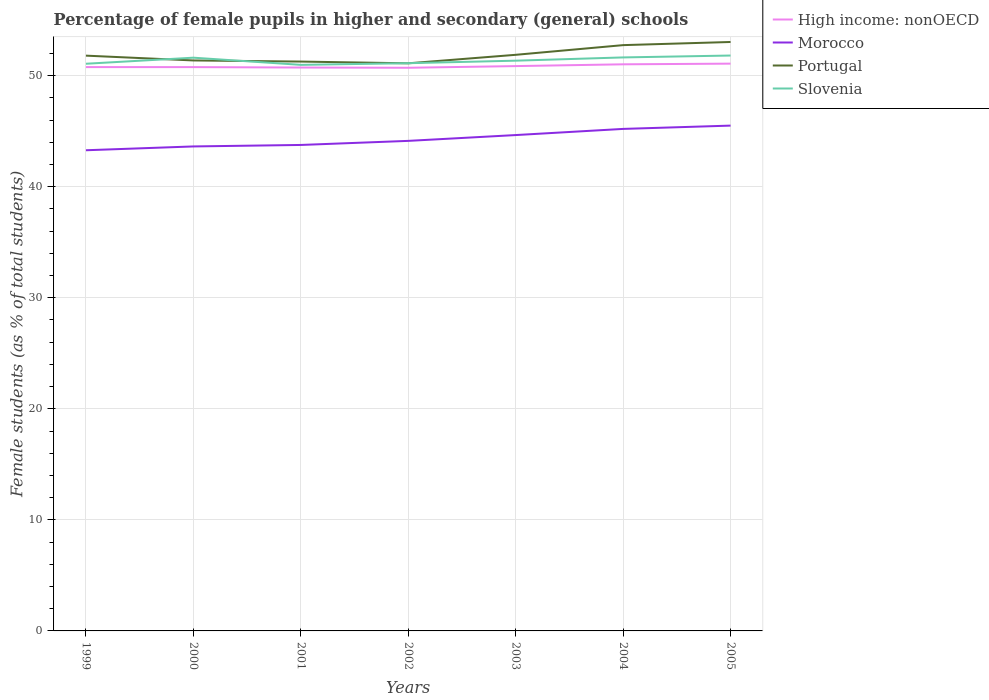Does the line corresponding to Slovenia intersect with the line corresponding to High income: nonOECD?
Offer a very short reply. No. Is the number of lines equal to the number of legend labels?
Provide a succinct answer. Yes. Across all years, what is the maximum percentage of female pupils in higher and secondary schools in High income: nonOECD?
Offer a terse response. 50.71. What is the total percentage of female pupils in higher and secondary schools in High income: nonOECD in the graph?
Give a very brief answer. -0.25. What is the difference between the highest and the second highest percentage of female pupils in higher and secondary schools in High income: nonOECD?
Offer a terse response. 0.37. What is the difference between the highest and the lowest percentage of female pupils in higher and secondary schools in High income: nonOECD?
Provide a short and direct response. 3. How many years are there in the graph?
Your response must be concise. 7. What is the difference between two consecutive major ticks on the Y-axis?
Provide a succinct answer. 10. Are the values on the major ticks of Y-axis written in scientific E-notation?
Keep it short and to the point. No. How many legend labels are there?
Offer a terse response. 4. How are the legend labels stacked?
Ensure brevity in your answer.  Vertical. What is the title of the graph?
Your answer should be compact. Percentage of female pupils in higher and secondary (general) schools. Does "Chile" appear as one of the legend labels in the graph?
Give a very brief answer. No. What is the label or title of the Y-axis?
Offer a very short reply. Female students (as % of total students). What is the Female students (as % of total students) of High income: nonOECD in 1999?
Ensure brevity in your answer.  50.77. What is the Female students (as % of total students) in Morocco in 1999?
Make the answer very short. 43.28. What is the Female students (as % of total students) of Portugal in 1999?
Make the answer very short. 51.8. What is the Female students (as % of total students) in Slovenia in 1999?
Keep it short and to the point. 51.07. What is the Female students (as % of total students) in High income: nonOECD in 2000?
Ensure brevity in your answer.  50.77. What is the Female students (as % of total students) in Morocco in 2000?
Your response must be concise. 43.62. What is the Female students (as % of total students) in Portugal in 2000?
Ensure brevity in your answer.  51.37. What is the Female students (as % of total students) of Slovenia in 2000?
Your answer should be compact. 51.61. What is the Female students (as % of total students) in High income: nonOECD in 2001?
Give a very brief answer. 50.73. What is the Female students (as % of total students) in Morocco in 2001?
Your answer should be very brief. 43.76. What is the Female students (as % of total students) of Portugal in 2001?
Offer a terse response. 51.26. What is the Female students (as % of total students) of Slovenia in 2001?
Provide a succinct answer. 50.97. What is the Female students (as % of total students) in High income: nonOECD in 2002?
Ensure brevity in your answer.  50.71. What is the Female students (as % of total students) of Morocco in 2002?
Make the answer very short. 44.12. What is the Female students (as % of total students) in Portugal in 2002?
Give a very brief answer. 51.11. What is the Female students (as % of total students) in Slovenia in 2002?
Offer a very short reply. 51.12. What is the Female students (as % of total students) of High income: nonOECD in 2003?
Ensure brevity in your answer.  50.86. What is the Female students (as % of total students) of Morocco in 2003?
Offer a terse response. 44.65. What is the Female students (as % of total students) of Portugal in 2003?
Give a very brief answer. 51.87. What is the Female students (as % of total students) of Slovenia in 2003?
Provide a short and direct response. 51.35. What is the Female students (as % of total students) in High income: nonOECD in 2004?
Ensure brevity in your answer.  51.02. What is the Female students (as % of total students) of Morocco in 2004?
Offer a very short reply. 45.2. What is the Female students (as % of total students) of Portugal in 2004?
Offer a terse response. 52.74. What is the Female students (as % of total students) of Slovenia in 2004?
Make the answer very short. 51.64. What is the Female students (as % of total students) of High income: nonOECD in 2005?
Your answer should be compact. 51.08. What is the Female students (as % of total students) of Morocco in 2005?
Your answer should be very brief. 45.5. What is the Female students (as % of total students) in Portugal in 2005?
Provide a succinct answer. 53.03. What is the Female students (as % of total students) of Slovenia in 2005?
Offer a terse response. 51.81. Across all years, what is the maximum Female students (as % of total students) in High income: nonOECD?
Your answer should be compact. 51.08. Across all years, what is the maximum Female students (as % of total students) in Morocco?
Your response must be concise. 45.5. Across all years, what is the maximum Female students (as % of total students) in Portugal?
Offer a very short reply. 53.03. Across all years, what is the maximum Female students (as % of total students) in Slovenia?
Make the answer very short. 51.81. Across all years, what is the minimum Female students (as % of total students) of High income: nonOECD?
Your response must be concise. 50.71. Across all years, what is the minimum Female students (as % of total students) of Morocco?
Ensure brevity in your answer.  43.28. Across all years, what is the minimum Female students (as % of total students) in Portugal?
Offer a terse response. 51.11. Across all years, what is the minimum Female students (as % of total students) of Slovenia?
Your answer should be very brief. 50.97. What is the total Female students (as % of total students) of High income: nonOECD in the graph?
Your answer should be very brief. 355.92. What is the total Female students (as % of total students) in Morocco in the graph?
Keep it short and to the point. 310.13. What is the total Female students (as % of total students) in Portugal in the graph?
Offer a very short reply. 363.18. What is the total Female students (as % of total students) in Slovenia in the graph?
Give a very brief answer. 359.56. What is the difference between the Female students (as % of total students) in High income: nonOECD in 1999 and that in 2000?
Offer a very short reply. 0. What is the difference between the Female students (as % of total students) in Morocco in 1999 and that in 2000?
Ensure brevity in your answer.  -0.34. What is the difference between the Female students (as % of total students) in Portugal in 1999 and that in 2000?
Offer a very short reply. 0.43. What is the difference between the Female students (as % of total students) in Slovenia in 1999 and that in 2000?
Offer a very short reply. -0.55. What is the difference between the Female students (as % of total students) of High income: nonOECD in 1999 and that in 2001?
Keep it short and to the point. 0.04. What is the difference between the Female students (as % of total students) in Morocco in 1999 and that in 2001?
Ensure brevity in your answer.  -0.48. What is the difference between the Female students (as % of total students) of Portugal in 1999 and that in 2001?
Your answer should be compact. 0.53. What is the difference between the Female students (as % of total students) of Slovenia in 1999 and that in 2001?
Offer a terse response. 0.1. What is the difference between the Female students (as % of total students) in High income: nonOECD in 1999 and that in 2002?
Your answer should be very brief. 0.06. What is the difference between the Female students (as % of total students) in Morocco in 1999 and that in 2002?
Your response must be concise. -0.85. What is the difference between the Female students (as % of total students) in Portugal in 1999 and that in 2002?
Provide a succinct answer. 0.69. What is the difference between the Female students (as % of total students) of Slovenia in 1999 and that in 2002?
Offer a terse response. -0.05. What is the difference between the Female students (as % of total students) in High income: nonOECD in 1999 and that in 2003?
Offer a very short reply. -0.09. What is the difference between the Female students (as % of total students) of Morocco in 1999 and that in 2003?
Make the answer very short. -1.37. What is the difference between the Female students (as % of total students) in Portugal in 1999 and that in 2003?
Your answer should be very brief. -0.07. What is the difference between the Female students (as % of total students) in Slovenia in 1999 and that in 2003?
Ensure brevity in your answer.  -0.28. What is the difference between the Female students (as % of total students) of Morocco in 1999 and that in 2004?
Ensure brevity in your answer.  -1.92. What is the difference between the Female students (as % of total students) of Portugal in 1999 and that in 2004?
Provide a short and direct response. -0.95. What is the difference between the Female students (as % of total students) in Slovenia in 1999 and that in 2004?
Offer a terse response. -0.57. What is the difference between the Female students (as % of total students) of High income: nonOECD in 1999 and that in 2005?
Provide a short and direct response. -0.31. What is the difference between the Female students (as % of total students) in Morocco in 1999 and that in 2005?
Provide a short and direct response. -2.22. What is the difference between the Female students (as % of total students) of Portugal in 1999 and that in 2005?
Your response must be concise. -1.23. What is the difference between the Female students (as % of total students) of Slovenia in 1999 and that in 2005?
Offer a very short reply. -0.74. What is the difference between the Female students (as % of total students) in High income: nonOECD in 2000 and that in 2001?
Your response must be concise. 0.04. What is the difference between the Female students (as % of total students) of Morocco in 2000 and that in 2001?
Offer a very short reply. -0.13. What is the difference between the Female students (as % of total students) of Portugal in 2000 and that in 2001?
Give a very brief answer. 0.1. What is the difference between the Female students (as % of total students) in Slovenia in 2000 and that in 2001?
Keep it short and to the point. 0.65. What is the difference between the Female students (as % of total students) of High income: nonOECD in 2000 and that in 2002?
Your answer should be very brief. 0.06. What is the difference between the Female students (as % of total students) of Morocco in 2000 and that in 2002?
Provide a short and direct response. -0.5. What is the difference between the Female students (as % of total students) of Portugal in 2000 and that in 2002?
Provide a short and direct response. 0.26. What is the difference between the Female students (as % of total students) in Slovenia in 2000 and that in 2002?
Provide a short and direct response. 0.5. What is the difference between the Female students (as % of total students) of High income: nonOECD in 2000 and that in 2003?
Give a very brief answer. -0.09. What is the difference between the Female students (as % of total students) of Morocco in 2000 and that in 2003?
Offer a terse response. -1.02. What is the difference between the Female students (as % of total students) in Portugal in 2000 and that in 2003?
Give a very brief answer. -0.51. What is the difference between the Female students (as % of total students) of Slovenia in 2000 and that in 2003?
Make the answer very short. 0.27. What is the difference between the Female students (as % of total students) in High income: nonOECD in 2000 and that in 2004?
Your answer should be very brief. -0.25. What is the difference between the Female students (as % of total students) of Morocco in 2000 and that in 2004?
Your response must be concise. -1.58. What is the difference between the Female students (as % of total students) in Portugal in 2000 and that in 2004?
Your answer should be very brief. -1.38. What is the difference between the Female students (as % of total students) in Slovenia in 2000 and that in 2004?
Your answer should be compact. -0.02. What is the difference between the Female students (as % of total students) of High income: nonOECD in 2000 and that in 2005?
Offer a terse response. -0.31. What is the difference between the Female students (as % of total students) in Morocco in 2000 and that in 2005?
Provide a succinct answer. -1.87. What is the difference between the Female students (as % of total students) in Portugal in 2000 and that in 2005?
Provide a succinct answer. -1.66. What is the difference between the Female students (as % of total students) in Slovenia in 2000 and that in 2005?
Provide a succinct answer. -0.19. What is the difference between the Female students (as % of total students) of High income: nonOECD in 2001 and that in 2002?
Offer a very short reply. 0.02. What is the difference between the Female students (as % of total students) in Morocco in 2001 and that in 2002?
Your response must be concise. -0.37. What is the difference between the Female students (as % of total students) in Portugal in 2001 and that in 2002?
Keep it short and to the point. 0.16. What is the difference between the Female students (as % of total students) of Slovenia in 2001 and that in 2002?
Keep it short and to the point. -0.15. What is the difference between the Female students (as % of total students) of High income: nonOECD in 2001 and that in 2003?
Provide a succinct answer. -0.13. What is the difference between the Female students (as % of total students) in Morocco in 2001 and that in 2003?
Ensure brevity in your answer.  -0.89. What is the difference between the Female students (as % of total students) in Portugal in 2001 and that in 2003?
Keep it short and to the point. -0.61. What is the difference between the Female students (as % of total students) in Slovenia in 2001 and that in 2003?
Offer a very short reply. -0.38. What is the difference between the Female students (as % of total students) in High income: nonOECD in 2001 and that in 2004?
Your answer should be compact. -0.29. What is the difference between the Female students (as % of total students) in Morocco in 2001 and that in 2004?
Your response must be concise. -1.44. What is the difference between the Female students (as % of total students) of Portugal in 2001 and that in 2004?
Offer a very short reply. -1.48. What is the difference between the Female students (as % of total students) in Slovenia in 2001 and that in 2004?
Make the answer very short. -0.67. What is the difference between the Female students (as % of total students) of High income: nonOECD in 2001 and that in 2005?
Your answer should be compact. -0.35. What is the difference between the Female students (as % of total students) in Morocco in 2001 and that in 2005?
Keep it short and to the point. -1.74. What is the difference between the Female students (as % of total students) in Portugal in 2001 and that in 2005?
Provide a short and direct response. -1.76. What is the difference between the Female students (as % of total students) of Slovenia in 2001 and that in 2005?
Offer a terse response. -0.84. What is the difference between the Female students (as % of total students) in High income: nonOECD in 2002 and that in 2003?
Ensure brevity in your answer.  -0.15. What is the difference between the Female students (as % of total students) of Morocco in 2002 and that in 2003?
Offer a very short reply. -0.52. What is the difference between the Female students (as % of total students) in Portugal in 2002 and that in 2003?
Your answer should be very brief. -0.76. What is the difference between the Female students (as % of total students) of Slovenia in 2002 and that in 2003?
Give a very brief answer. -0.23. What is the difference between the Female students (as % of total students) of High income: nonOECD in 2002 and that in 2004?
Give a very brief answer. -0.31. What is the difference between the Female students (as % of total students) of Morocco in 2002 and that in 2004?
Keep it short and to the point. -1.08. What is the difference between the Female students (as % of total students) of Portugal in 2002 and that in 2004?
Ensure brevity in your answer.  -1.64. What is the difference between the Female students (as % of total students) of Slovenia in 2002 and that in 2004?
Offer a very short reply. -0.52. What is the difference between the Female students (as % of total students) in High income: nonOECD in 2002 and that in 2005?
Give a very brief answer. -0.37. What is the difference between the Female students (as % of total students) of Morocco in 2002 and that in 2005?
Your response must be concise. -1.37. What is the difference between the Female students (as % of total students) in Portugal in 2002 and that in 2005?
Provide a succinct answer. -1.92. What is the difference between the Female students (as % of total students) in Slovenia in 2002 and that in 2005?
Your answer should be very brief. -0.69. What is the difference between the Female students (as % of total students) of High income: nonOECD in 2003 and that in 2004?
Keep it short and to the point. -0.16. What is the difference between the Female students (as % of total students) of Morocco in 2003 and that in 2004?
Ensure brevity in your answer.  -0.55. What is the difference between the Female students (as % of total students) of Portugal in 2003 and that in 2004?
Keep it short and to the point. -0.87. What is the difference between the Female students (as % of total students) of Slovenia in 2003 and that in 2004?
Your answer should be compact. -0.29. What is the difference between the Female students (as % of total students) in High income: nonOECD in 2003 and that in 2005?
Your answer should be very brief. -0.22. What is the difference between the Female students (as % of total students) in Morocco in 2003 and that in 2005?
Offer a terse response. -0.85. What is the difference between the Female students (as % of total students) of Portugal in 2003 and that in 2005?
Your answer should be compact. -1.15. What is the difference between the Female students (as % of total students) in Slovenia in 2003 and that in 2005?
Your answer should be compact. -0.46. What is the difference between the Female students (as % of total students) of High income: nonOECD in 2004 and that in 2005?
Keep it short and to the point. -0.06. What is the difference between the Female students (as % of total students) in Morocco in 2004 and that in 2005?
Offer a very short reply. -0.3. What is the difference between the Female students (as % of total students) of Portugal in 2004 and that in 2005?
Provide a succinct answer. -0.28. What is the difference between the Female students (as % of total students) of Slovenia in 2004 and that in 2005?
Ensure brevity in your answer.  -0.17. What is the difference between the Female students (as % of total students) in High income: nonOECD in 1999 and the Female students (as % of total students) in Morocco in 2000?
Offer a terse response. 7.14. What is the difference between the Female students (as % of total students) of High income: nonOECD in 1999 and the Female students (as % of total students) of Portugal in 2000?
Offer a terse response. -0.6. What is the difference between the Female students (as % of total students) of High income: nonOECD in 1999 and the Female students (as % of total students) of Slovenia in 2000?
Ensure brevity in your answer.  -0.85. What is the difference between the Female students (as % of total students) of Morocco in 1999 and the Female students (as % of total students) of Portugal in 2000?
Your response must be concise. -8.09. What is the difference between the Female students (as % of total students) in Morocco in 1999 and the Female students (as % of total students) in Slovenia in 2000?
Make the answer very short. -8.34. What is the difference between the Female students (as % of total students) of Portugal in 1999 and the Female students (as % of total students) of Slovenia in 2000?
Offer a terse response. 0.18. What is the difference between the Female students (as % of total students) of High income: nonOECD in 1999 and the Female students (as % of total students) of Morocco in 2001?
Give a very brief answer. 7.01. What is the difference between the Female students (as % of total students) in High income: nonOECD in 1999 and the Female students (as % of total students) in Portugal in 2001?
Your response must be concise. -0.5. What is the difference between the Female students (as % of total students) of High income: nonOECD in 1999 and the Female students (as % of total students) of Slovenia in 2001?
Make the answer very short. -0.2. What is the difference between the Female students (as % of total students) in Morocco in 1999 and the Female students (as % of total students) in Portugal in 2001?
Your answer should be compact. -7.99. What is the difference between the Female students (as % of total students) of Morocco in 1999 and the Female students (as % of total students) of Slovenia in 2001?
Make the answer very short. -7.69. What is the difference between the Female students (as % of total students) in Portugal in 1999 and the Female students (as % of total students) in Slovenia in 2001?
Your answer should be very brief. 0.83. What is the difference between the Female students (as % of total students) in High income: nonOECD in 1999 and the Female students (as % of total students) in Morocco in 2002?
Your response must be concise. 6.64. What is the difference between the Female students (as % of total students) of High income: nonOECD in 1999 and the Female students (as % of total students) of Portugal in 2002?
Your answer should be very brief. -0.34. What is the difference between the Female students (as % of total students) in High income: nonOECD in 1999 and the Female students (as % of total students) in Slovenia in 2002?
Give a very brief answer. -0.35. What is the difference between the Female students (as % of total students) of Morocco in 1999 and the Female students (as % of total students) of Portugal in 2002?
Make the answer very short. -7.83. What is the difference between the Female students (as % of total students) of Morocco in 1999 and the Female students (as % of total students) of Slovenia in 2002?
Provide a short and direct response. -7.84. What is the difference between the Female students (as % of total students) in Portugal in 1999 and the Female students (as % of total students) in Slovenia in 2002?
Ensure brevity in your answer.  0.68. What is the difference between the Female students (as % of total students) of High income: nonOECD in 1999 and the Female students (as % of total students) of Morocco in 2003?
Offer a terse response. 6.12. What is the difference between the Female students (as % of total students) in High income: nonOECD in 1999 and the Female students (as % of total students) in Portugal in 2003?
Provide a short and direct response. -1.11. What is the difference between the Female students (as % of total students) of High income: nonOECD in 1999 and the Female students (as % of total students) of Slovenia in 2003?
Offer a terse response. -0.58. What is the difference between the Female students (as % of total students) of Morocco in 1999 and the Female students (as % of total students) of Portugal in 2003?
Offer a terse response. -8.59. What is the difference between the Female students (as % of total students) of Morocco in 1999 and the Female students (as % of total students) of Slovenia in 2003?
Provide a short and direct response. -8.07. What is the difference between the Female students (as % of total students) in Portugal in 1999 and the Female students (as % of total students) in Slovenia in 2003?
Your answer should be very brief. 0.45. What is the difference between the Female students (as % of total students) in High income: nonOECD in 1999 and the Female students (as % of total students) in Morocco in 2004?
Your response must be concise. 5.57. What is the difference between the Female students (as % of total students) in High income: nonOECD in 1999 and the Female students (as % of total students) in Portugal in 2004?
Your response must be concise. -1.98. What is the difference between the Female students (as % of total students) in High income: nonOECD in 1999 and the Female students (as % of total students) in Slovenia in 2004?
Provide a short and direct response. -0.87. What is the difference between the Female students (as % of total students) in Morocco in 1999 and the Female students (as % of total students) in Portugal in 2004?
Provide a short and direct response. -9.47. What is the difference between the Female students (as % of total students) of Morocco in 1999 and the Female students (as % of total students) of Slovenia in 2004?
Make the answer very short. -8.36. What is the difference between the Female students (as % of total students) in Portugal in 1999 and the Female students (as % of total students) in Slovenia in 2004?
Your answer should be compact. 0.16. What is the difference between the Female students (as % of total students) of High income: nonOECD in 1999 and the Female students (as % of total students) of Morocco in 2005?
Offer a very short reply. 5.27. What is the difference between the Female students (as % of total students) of High income: nonOECD in 1999 and the Female students (as % of total students) of Portugal in 2005?
Provide a succinct answer. -2.26. What is the difference between the Female students (as % of total students) in High income: nonOECD in 1999 and the Female students (as % of total students) in Slovenia in 2005?
Provide a succinct answer. -1.04. What is the difference between the Female students (as % of total students) of Morocco in 1999 and the Female students (as % of total students) of Portugal in 2005?
Keep it short and to the point. -9.75. What is the difference between the Female students (as % of total students) in Morocco in 1999 and the Female students (as % of total students) in Slovenia in 2005?
Your answer should be very brief. -8.53. What is the difference between the Female students (as % of total students) in Portugal in 1999 and the Female students (as % of total students) in Slovenia in 2005?
Your answer should be compact. -0.01. What is the difference between the Female students (as % of total students) of High income: nonOECD in 2000 and the Female students (as % of total students) of Morocco in 2001?
Your answer should be compact. 7.01. What is the difference between the Female students (as % of total students) of High income: nonOECD in 2000 and the Female students (as % of total students) of Portugal in 2001?
Your answer should be compact. -0.5. What is the difference between the Female students (as % of total students) of High income: nonOECD in 2000 and the Female students (as % of total students) of Slovenia in 2001?
Your answer should be compact. -0.2. What is the difference between the Female students (as % of total students) in Morocco in 2000 and the Female students (as % of total students) in Portugal in 2001?
Offer a very short reply. -7.64. What is the difference between the Female students (as % of total students) of Morocco in 2000 and the Female students (as % of total students) of Slovenia in 2001?
Offer a terse response. -7.35. What is the difference between the Female students (as % of total students) in Portugal in 2000 and the Female students (as % of total students) in Slovenia in 2001?
Your answer should be very brief. 0.4. What is the difference between the Female students (as % of total students) in High income: nonOECD in 2000 and the Female students (as % of total students) in Morocco in 2002?
Your response must be concise. 6.64. What is the difference between the Female students (as % of total students) of High income: nonOECD in 2000 and the Female students (as % of total students) of Portugal in 2002?
Keep it short and to the point. -0.34. What is the difference between the Female students (as % of total students) of High income: nonOECD in 2000 and the Female students (as % of total students) of Slovenia in 2002?
Provide a succinct answer. -0.35. What is the difference between the Female students (as % of total students) of Morocco in 2000 and the Female students (as % of total students) of Portugal in 2002?
Keep it short and to the point. -7.48. What is the difference between the Female students (as % of total students) of Morocco in 2000 and the Female students (as % of total students) of Slovenia in 2002?
Your response must be concise. -7.49. What is the difference between the Female students (as % of total students) in Portugal in 2000 and the Female students (as % of total students) in Slovenia in 2002?
Provide a short and direct response. 0.25. What is the difference between the Female students (as % of total students) of High income: nonOECD in 2000 and the Female students (as % of total students) of Morocco in 2003?
Provide a short and direct response. 6.12. What is the difference between the Female students (as % of total students) in High income: nonOECD in 2000 and the Female students (as % of total students) in Portugal in 2003?
Make the answer very short. -1.11. What is the difference between the Female students (as % of total students) in High income: nonOECD in 2000 and the Female students (as % of total students) in Slovenia in 2003?
Provide a short and direct response. -0.58. What is the difference between the Female students (as % of total students) of Morocco in 2000 and the Female students (as % of total students) of Portugal in 2003?
Give a very brief answer. -8.25. What is the difference between the Female students (as % of total students) of Morocco in 2000 and the Female students (as % of total students) of Slovenia in 2003?
Ensure brevity in your answer.  -7.72. What is the difference between the Female students (as % of total students) in Portugal in 2000 and the Female students (as % of total students) in Slovenia in 2003?
Keep it short and to the point. 0.02. What is the difference between the Female students (as % of total students) of High income: nonOECD in 2000 and the Female students (as % of total students) of Morocco in 2004?
Keep it short and to the point. 5.56. What is the difference between the Female students (as % of total students) of High income: nonOECD in 2000 and the Female students (as % of total students) of Portugal in 2004?
Your answer should be very brief. -1.98. What is the difference between the Female students (as % of total students) of High income: nonOECD in 2000 and the Female students (as % of total students) of Slovenia in 2004?
Give a very brief answer. -0.87. What is the difference between the Female students (as % of total students) in Morocco in 2000 and the Female students (as % of total students) in Portugal in 2004?
Give a very brief answer. -9.12. What is the difference between the Female students (as % of total students) of Morocco in 2000 and the Female students (as % of total students) of Slovenia in 2004?
Your answer should be very brief. -8.02. What is the difference between the Female students (as % of total students) of Portugal in 2000 and the Female students (as % of total students) of Slovenia in 2004?
Your answer should be very brief. -0.27. What is the difference between the Female students (as % of total students) of High income: nonOECD in 2000 and the Female students (as % of total students) of Morocco in 2005?
Offer a very short reply. 5.27. What is the difference between the Female students (as % of total students) of High income: nonOECD in 2000 and the Female students (as % of total students) of Portugal in 2005?
Ensure brevity in your answer.  -2.26. What is the difference between the Female students (as % of total students) in High income: nonOECD in 2000 and the Female students (as % of total students) in Slovenia in 2005?
Ensure brevity in your answer.  -1.04. What is the difference between the Female students (as % of total students) in Morocco in 2000 and the Female students (as % of total students) in Portugal in 2005?
Your answer should be very brief. -9.4. What is the difference between the Female students (as % of total students) in Morocco in 2000 and the Female students (as % of total students) in Slovenia in 2005?
Your answer should be compact. -8.19. What is the difference between the Female students (as % of total students) in Portugal in 2000 and the Female students (as % of total students) in Slovenia in 2005?
Give a very brief answer. -0.44. What is the difference between the Female students (as % of total students) of High income: nonOECD in 2001 and the Female students (as % of total students) of Morocco in 2002?
Provide a succinct answer. 6.6. What is the difference between the Female students (as % of total students) of High income: nonOECD in 2001 and the Female students (as % of total students) of Portugal in 2002?
Your answer should be very brief. -0.38. What is the difference between the Female students (as % of total students) of High income: nonOECD in 2001 and the Female students (as % of total students) of Slovenia in 2002?
Offer a very short reply. -0.39. What is the difference between the Female students (as % of total students) in Morocco in 2001 and the Female students (as % of total students) in Portugal in 2002?
Ensure brevity in your answer.  -7.35. What is the difference between the Female students (as % of total students) of Morocco in 2001 and the Female students (as % of total students) of Slovenia in 2002?
Make the answer very short. -7.36. What is the difference between the Female students (as % of total students) in Portugal in 2001 and the Female students (as % of total students) in Slovenia in 2002?
Make the answer very short. 0.15. What is the difference between the Female students (as % of total students) in High income: nonOECD in 2001 and the Female students (as % of total students) in Morocco in 2003?
Give a very brief answer. 6.08. What is the difference between the Female students (as % of total students) in High income: nonOECD in 2001 and the Female students (as % of total students) in Portugal in 2003?
Your answer should be very brief. -1.15. What is the difference between the Female students (as % of total students) in High income: nonOECD in 2001 and the Female students (as % of total students) in Slovenia in 2003?
Offer a very short reply. -0.62. What is the difference between the Female students (as % of total students) of Morocco in 2001 and the Female students (as % of total students) of Portugal in 2003?
Offer a very short reply. -8.12. What is the difference between the Female students (as % of total students) of Morocco in 2001 and the Female students (as % of total students) of Slovenia in 2003?
Make the answer very short. -7.59. What is the difference between the Female students (as % of total students) of Portugal in 2001 and the Female students (as % of total students) of Slovenia in 2003?
Ensure brevity in your answer.  -0.08. What is the difference between the Female students (as % of total students) in High income: nonOECD in 2001 and the Female students (as % of total students) in Morocco in 2004?
Provide a short and direct response. 5.53. What is the difference between the Female students (as % of total students) in High income: nonOECD in 2001 and the Female students (as % of total students) in Portugal in 2004?
Your answer should be compact. -2.02. What is the difference between the Female students (as % of total students) of High income: nonOECD in 2001 and the Female students (as % of total students) of Slovenia in 2004?
Your answer should be very brief. -0.91. What is the difference between the Female students (as % of total students) of Morocco in 2001 and the Female students (as % of total students) of Portugal in 2004?
Offer a terse response. -8.99. What is the difference between the Female students (as % of total students) of Morocco in 2001 and the Female students (as % of total students) of Slovenia in 2004?
Your answer should be very brief. -7.88. What is the difference between the Female students (as % of total students) of Portugal in 2001 and the Female students (as % of total students) of Slovenia in 2004?
Offer a terse response. -0.37. What is the difference between the Female students (as % of total students) in High income: nonOECD in 2001 and the Female students (as % of total students) in Morocco in 2005?
Your answer should be compact. 5.23. What is the difference between the Female students (as % of total students) in High income: nonOECD in 2001 and the Female students (as % of total students) in Portugal in 2005?
Provide a succinct answer. -2.3. What is the difference between the Female students (as % of total students) in High income: nonOECD in 2001 and the Female students (as % of total students) in Slovenia in 2005?
Give a very brief answer. -1.08. What is the difference between the Female students (as % of total students) in Morocco in 2001 and the Female students (as % of total students) in Portugal in 2005?
Make the answer very short. -9.27. What is the difference between the Female students (as % of total students) in Morocco in 2001 and the Female students (as % of total students) in Slovenia in 2005?
Keep it short and to the point. -8.05. What is the difference between the Female students (as % of total students) of Portugal in 2001 and the Female students (as % of total students) of Slovenia in 2005?
Your answer should be compact. -0.54. What is the difference between the Female students (as % of total students) in High income: nonOECD in 2002 and the Female students (as % of total students) in Morocco in 2003?
Ensure brevity in your answer.  6.06. What is the difference between the Female students (as % of total students) of High income: nonOECD in 2002 and the Female students (as % of total students) of Portugal in 2003?
Your answer should be very brief. -1.17. What is the difference between the Female students (as % of total students) in High income: nonOECD in 2002 and the Female students (as % of total students) in Slovenia in 2003?
Make the answer very short. -0.64. What is the difference between the Female students (as % of total students) in Morocco in 2002 and the Female students (as % of total students) in Portugal in 2003?
Your answer should be compact. -7.75. What is the difference between the Female students (as % of total students) in Morocco in 2002 and the Female students (as % of total students) in Slovenia in 2003?
Keep it short and to the point. -7.22. What is the difference between the Female students (as % of total students) of Portugal in 2002 and the Female students (as % of total students) of Slovenia in 2003?
Offer a very short reply. -0.24. What is the difference between the Female students (as % of total students) of High income: nonOECD in 2002 and the Female students (as % of total students) of Morocco in 2004?
Provide a succinct answer. 5.5. What is the difference between the Female students (as % of total students) in High income: nonOECD in 2002 and the Female students (as % of total students) in Portugal in 2004?
Offer a terse response. -2.04. What is the difference between the Female students (as % of total students) of High income: nonOECD in 2002 and the Female students (as % of total students) of Slovenia in 2004?
Your answer should be very brief. -0.93. What is the difference between the Female students (as % of total students) of Morocco in 2002 and the Female students (as % of total students) of Portugal in 2004?
Your answer should be very brief. -8.62. What is the difference between the Female students (as % of total students) of Morocco in 2002 and the Female students (as % of total students) of Slovenia in 2004?
Provide a succinct answer. -7.51. What is the difference between the Female students (as % of total students) in Portugal in 2002 and the Female students (as % of total students) in Slovenia in 2004?
Make the answer very short. -0.53. What is the difference between the Female students (as % of total students) of High income: nonOECD in 2002 and the Female students (as % of total students) of Morocco in 2005?
Ensure brevity in your answer.  5.21. What is the difference between the Female students (as % of total students) in High income: nonOECD in 2002 and the Female students (as % of total students) in Portugal in 2005?
Offer a very short reply. -2.32. What is the difference between the Female students (as % of total students) in High income: nonOECD in 2002 and the Female students (as % of total students) in Slovenia in 2005?
Keep it short and to the point. -1.1. What is the difference between the Female students (as % of total students) of Morocco in 2002 and the Female students (as % of total students) of Portugal in 2005?
Provide a short and direct response. -8.9. What is the difference between the Female students (as % of total students) of Morocco in 2002 and the Female students (as % of total students) of Slovenia in 2005?
Give a very brief answer. -7.68. What is the difference between the Female students (as % of total students) of Portugal in 2002 and the Female students (as % of total students) of Slovenia in 2005?
Make the answer very short. -0.7. What is the difference between the Female students (as % of total students) in High income: nonOECD in 2003 and the Female students (as % of total students) in Morocco in 2004?
Your answer should be compact. 5.66. What is the difference between the Female students (as % of total students) of High income: nonOECD in 2003 and the Female students (as % of total students) of Portugal in 2004?
Offer a terse response. -1.89. What is the difference between the Female students (as % of total students) in High income: nonOECD in 2003 and the Female students (as % of total students) in Slovenia in 2004?
Provide a short and direct response. -0.78. What is the difference between the Female students (as % of total students) of Morocco in 2003 and the Female students (as % of total students) of Portugal in 2004?
Offer a very short reply. -8.1. What is the difference between the Female students (as % of total students) of Morocco in 2003 and the Female students (as % of total students) of Slovenia in 2004?
Make the answer very short. -6.99. What is the difference between the Female students (as % of total students) in Portugal in 2003 and the Female students (as % of total students) in Slovenia in 2004?
Make the answer very short. 0.23. What is the difference between the Female students (as % of total students) in High income: nonOECD in 2003 and the Female students (as % of total students) in Morocco in 2005?
Give a very brief answer. 5.36. What is the difference between the Female students (as % of total students) of High income: nonOECD in 2003 and the Female students (as % of total students) of Portugal in 2005?
Your answer should be compact. -2.17. What is the difference between the Female students (as % of total students) of High income: nonOECD in 2003 and the Female students (as % of total students) of Slovenia in 2005?
Your answer should be compact. -0.95. What is the difference between the Female students (as % of total students) in Morocco in 2003 and the Female students (as % of total students) in Portugal in 2005?
Provide a short and direct response. -8.38. What is the difference between the Female students (as % of total students) of Morocco in 2003 and the Female students (as % of total students) of Slovenia in 2005?
Ensure brevity in your answer.  -7.16. What is the difference between the Female students (as % of total students) of Portugal in 2003 and the Female students (as % of total students) of Slovenia in 2005?
Offer a terse response. 0.06. What is the difference between the Female students (as % of total students) of High income: nonOECD in 2004 and the Female students (as % of total students) of Morocco in 2005?
Provide a succinct answer. 5.52. What is the difference between the Female students (as % of total students) in High income: nonOECD in 2004 and the Female students (as % of total students) in Portugal in 2005?
Keep it short and to the point. -2.01. What is the difference between the Female students (as % of total students) of High income: nonOECD in 2004 and the Female students (as % of total students) of Slovenia in 2005?
Provide a succinct answer. -0.79. What is the difference between the Female students (as % of total students) in Morocco in 2004 and the Female students (as % of total students) in Portugal in 2005?
Your answer should be very brief. -7.83. What is the difference between the Female students (as % of total students) in Morocco in 2004 and the Female students (as % of total students) in Slovenia in 2005?
Offer a very short reply. -6.61. What is the difference between the Female students (as % of total students) in Portugal in 2004 and the Female students (as % of total students) in Slovenia in 2005?
Provide a short and direct response. 0.94. What is the average Female students (as % of total students) in High income: nonOECD per year?
Your answer should be compact. 50.85. What is the average Female students (as % of total students) in Morocco per year?
Keep it short and to the point. 44.3. What is the average Female students (as % of total students) of Portugal per year?
Your answer should be very brief. 51.88. What is the average Female students (as % of total students) in Slovenia per year?
Ensure brevity in your answer.  51.37. In the year 1999, what is the difference between the Female students (as % of total students) in High income: nonOECD and Female students (as % of total students) in Morocco?
Make the answer very short. 7.49. In the year 1999, what is the difference between the Female students (as % of total students) in High income: nonOECD and Female students (as % of total students) in Portugal?
Your response must be concise. -1.03. In the year 1999, what is the difference between the Female students (as % of total students) in High income: nonOECD and Female students (as % of total students) in Slovenia?
Offer a very short reply. -0.3. In the year 1999, what is the difference between the Female students (as % of total students) of Morocco and Female students (as % of total students) of Portugal?
Your response must be concise. -8.52. In the year 1999, what is the difference between the Female students (as % of total students) in Morocco and Female students (as % of total students) in Slovenia?
Ensure brevity in your answer.  -7.79. In the year 1999, what is the difference between the Female students (as % of total students) in Portugal and Female students (as % of total students) in Slovenia?
Offer a very short reply. 0.73. In the year 2000, what is the difference between the Female students (as % of total students) of High income: nonOECD and Female students (as % of total students) of Morocco?
Offer a terse response. 7.14. In the year 2000, what is the difference between the Female students (as % of total students) in High income: nonOECD and Female students (as % of total students) in Portugal?
Your response must be concise. -0.6. In the year 2000, what is the difference between the Female students (as % of total students) of High income: nonOECD and Female students (as % of total students) of Slovenia?
Provide a short and direct response. -0.85. In the year 2000, what is the difference between the Female students (as % of total students) of Morocco and Female students (as % of total students) of Portugal?
Your response must be concise. -7.74. In the year 2000, what is the difference between the Female students (as % of total students) of Morocco and Female students (as % of total students) of Slovenia?
Your answer should be compact. -7.99. In the year 2000, what is the difference between the Female students (as % of total students) of Portugal and Female students (as % of total students) of Slovenia?
Offer a terse response. -0.25. In the year 2001, what is the difference between the Female students (as % of total students) in High income: nonOECD and Female students (as % of total students) in Morocco?
Ensure brevity in your answer.  6.97. In the year 2001, what is the difference between the Female students (as % of total students) of High income: nonOECD and Female students (as % of total students) of Portugal?
Your response must be concise. -0.54. In the year 2001, what is the difference between the Female students (as % of total students) of High income: nonOECD and Female students (as % of total students) of Slovenia?
Offer a very short reply. -0.24. In the year 2001, what is the difference between the Female students (as % of total students) of Morocco and Female students (as % of total students) of Portugal?
Make the answer very short. -7.51. In the year 2001, what is the difference between the Female students (as % of total students) in Morocco and Female students (as % of total students) in Slovenia?
Your response must be concise. -7.21. In the year 2001, what is the difference between the Female students (as % of total students) in Portugal and Female students (as % of total students) in Slovenia?
Make the answer very short. 0.3. In the year 2002, what is the difference between the Female students (as % of total students) in High income: nonOECD and Female students (as % of total students) in Morocco?
Your response must be concise. 6.58. In the year 2002, what is the difference between the Female students (as % of total students) in High income: nonOECD and Female students (as % of total students) in Portugal?
Offer a terse response. -0.4. In the year 2002, what is the difference between the Female students (as % of total students) in High income: nonOECD and Female students (as % of total students) in Slovenia?
Provide a succinct answer. -0.41. In the year 2002, what is the difference between the Female students (as % of total students) of Morocco and Female students (as % of total students) of Portugal?
Give a very brief answer. -6.98. In the year 2002, what is the difference between the Female students (as % of total students) in Morocco and Female students (as % of total students) in Slovenia?
Provide a succinct answer. -6.99. In the year 2002, what is the difference between the Female students (as % of total students) of Portugal and Female students (as % of total students) of Slovenia?
Provide a short and direct response. -0.01. In the year 2003, what is the difference between the Female students (as % of total students) of High income: nonOECD and Female students (as % of total students) of Morocco?
Provide a succinct answer. 6.21. In the year 2003, what is the difference between the Female students (as % of total students) of High income: nonOECD and Female students (as % of total students) of Portugal?
Offer a terse response. -1.02. In the year 2003, what is the difference between the Female students (as % of total students) of High income: nonOECD and Female students (as % of total students) of Slovenia?
Give a very brief answer. -0.49. In the year 2003, what is the difference between the Female students (as % of total students) in Morocco and Female students (as % of total students) in Portugal?
Your answer should be very brief. -7.23. In the year 2003, what is the difference between the Female students (as % of total students) in Morocco and Female students (as % of total students) in Slovenia?
Offer a terse response. -6.7. In the year 2003, what is the difference between the Female students (as % of total students) in Portugal and Female students (as % of total students) in Slovenia?
Give a very brief answer. 0.53. In the year 2004, what is the difference between the Female students (as % of total students) in High income: nonOECD and Female students (as % of total students) in Morocco?
Offer a terse response. 5.82. In the year 2004, what is the difference between the Female students (as % of total students) in High income: nonOECD and Female students (as % of total students) in Portugal?
Provide a succinct answer. -1.73. In the year 2004, what is the difference between the Female students (as % of total students) in High income: nonOECD and Female students (as % of total students) in Slovenia?
Offer a very short reply. -0.62. In the year 2004, what is the difference between the Female students (as % of total students) of Morocco and Female students (as % of total students) of Portugal?
Your response must be concise. -7.54. In the year 2004, what is the difference between the Female students (as % of total students) of Morocco and Female students (as % of total students) of Slovenia?
Give a very brief answer. -6.44. In the year 2004, what is the difference between the Female students (as % of total students) of Portugal and Female students (as % of total students) of Slovenia?
Provide a short and direct response. 1.11. In the year 2005, what is the difference between the Female students (as % of total students) of High income: nonOECD and Female students (as % of total students) of Morocco?
Your answer should be compact. 5.58. In the year 2005, what is the difference between the Female students (as % of total students) of High income: nonOECD and Female students (as % of total students) of Portugal?
Keep it short and to the point. -1.95. In the year 2005, what is the difference between the Female students (as % of total students) in High income: nonOECD and Female students (as % of total students) in Slovenia?
Keep it short and to the point. -0.73. In the year 2005, what is the difference between the Female students (as % of total students) of Morocco and Female students (as % of total students) of Portugal?
Give a very brief answer. -7.53. In the year 2005, what is the difference between the Female students (as % of total students) of Morocco and Female students (as % of total students) of Slovenia?
Your answer should be very brief. -6.31. In the year 2005, what is the difference between the Female students (as % of total students) of Portugal and Female students (as % of total students) of Slovenia?
Keep it short and to the point. 1.22. What is the ratio of the Female students (as % of total students) in High income: nonOECD in 1999 to that in 2000?
Keep it short and to the point. 1. What is the ratio of the Female students (as % of total students) in Portugal in 1999 to that in 2000?
Provide a short and direct response. 1.01. What is the ratio of the Female students (as % of total students) of High income: nonOECD in 1999 to that in 2001?
Your answer should be compact. 1. What is the ratio of the Female students (as % of total students) of Portugal in 1999 to that in 2001?
Offer a terse response. 1.01. What is the ratio of the Female students (as % of total students) of High income: nonOECD in 1999 to that in 2002?
Your response must be concise. 1. What is the ratio of the Female students (as % of total students) in Morocco in 1999 to that in 2002?
Keep it short and to the point. 0.98. What is the ratio of the Female students (as % of total students) in Portugal in 1999 to that in 2002?
Offer a very short reply. 1.01. What is the ratio of the Female students (as % of total students) in Morocco in 1999 to that in 2003?
Offer a terse response. 0.97. What is the ratio of the Female students (as % of total students) in Slovenia in 1999 to that in 2003?
Ensure brevity in your answer.  0.99. What is the ratio of the Female students (as % of total students) in Morocco in 1999 to that in 2004?
Your answer should be compact. 0.96. What is the ratio of the Female students (as % of total students) of Portugal in 1999 to that in 2004?
Give a very brief answer. 0.98. What is the ratio of the Female students (as % of total students) in Slovenia in 1999 to that in 2004?
Your response must be concise. 0.99. What is the ratio of the Female students (as % of total students) of Morocco in 1999 to that in 2005?
Offer a very short reply. 0.95. What is the ratio of the Female students (as % of total students) of Portugal in 1999 to that in 2005?
Provide a succinct answer. 0.98. What is the ratio of the Female students (as % of total students) of Slovenia in 1999 to that in 2005?
Offer a terse response. 0.99. What is the ratio of the Female students (as % of total students) in High income: nonOECD in 2000 to that in 2001?
Ensure brevity in your answer.  1. What is the ratio of the Female students (as % of total students) in Slovenia in 2000 to that in 2001?
Provide a short and direct response. 1.01. What is the ratio of the Female students (as % of total students) in High income: nonOECD in 2000 to that in 2002?
Offer a terse response. 1. What is the ratio of the Female students (as % of total students) of Slovenia in 2000 to that in 2002?
Provide a short and direct response. 1.01. What is the ratio of the Female students (as % of total students) in High income: nonOECD in 2000 to that in 2003?
Your answer should be very brief. 1. What is the ratio of the Female students (as % of total students) of Morocco in 2000 to that in 2003?
Make the answer very short. 0.98. What is the ratio of the Female students (as % of total students) in Portugal in 2000 to that in 2003?
Offer a very short reply. 0.99. What is the ratio of the Female students (as % of total students) of Slovenia in 2000 to that in 2003?
Make the answer very short. 1.01. What is the ratio of the Female students (as % of total students) in High income: nonOECD in 2000 to that in 2004?
Your answer should be compact. 1. What is the ratio of the Female students (as % of total students) of Morocco in 2000 to that in 2004?
Keep it short and to the point. 0.97. What is the ratio of the Female students (as % of total students) of Portugal in 2000 to that in 2004?
Offer a very short reply. 0.97. What is the ratio of the Female students (as % of total students) in High income: nonOECD in 2000 to that in 2005?
Offer a very short reply. 0.99. What is the ratio of the Female students (as % of total students) in Morocco in 2000 to that in 2005?
Offer a terse response. 0.96. What is the ratio of the Female students (as % of total students) in Portugal in 2000 to that in 2005?
Offer a terse response. 0.97. What is the ratio of the Female students (as % of total students) in Slovenia in 2000 to that in 2005?
Keep it short and to the point. 1. What is the ratio of the Female students (as % of total students) in High income: nonOECD in 2001 to that in 2003?
Keep it short and to the point. 1. What is the ratio of the Female students (as % of total students) in Morocco in 2001 to that in 2003?
Provide a short and direct response. 0.98. What is the ratio of the Female students (as % of total students) of Portugal in 2001 to that in 2003?
Your response must be concise. 0.99. What is the ratio of the Female students (as % of total students) of Slovenia in 2001 to that in 2003?
Give a very brief answer. 0.99. What is the ratio of the Female students (as % of total students) of High income: nonOECD in 2001 to that in 2004?
Your answer should be compact. 0.99. What is the ratio of the Female students (as % of total students) of Morocco in 2001 to that in 2004?
Your response must be concise. 0.97. What is the ratio of the Female students (as % of total students) of Portugal in 2001 to that in 2004?
Give a very brief answer. 0.97. What is the ratio of the Female students (as % of total students) of Slovenia in 2001 to that in 2004?
Offer a very short reply. 0.99. What is the ratio of the Female students (as % of total students) in High income: nonOECD in 2001 to that in 2005?
Make the answer very short. 0.99. What is the ratio of the Female students (as % of total students) in Morocco in 2001 to that in 2005?
Your answer should be very brief. 0.96. What is the ratio of the Female students (as % of total students) in Portugal in 2001 to that in 2005?
Make the answer very short. 0.97. What is the ratio of the Female students (as % of total students) of Slovenia in 2001 to that in 2005?
Provide a short and direct response. 0.98. What is the ratio of the Female students (as % of total students) of Morocco in 2002 to that in 2003?
Your response must be concise. 0.99. What is the ratio of the Female students (as % of total students) of Slovenia in 2002 to that in 2003?
Give a very brief answer. 1. What is the ratio of the Female students (as % of total students) of Morocco in 2002 to that in 2004?
Provide a succinct answer. 0.98. What is the ratio of the Female students (as % of total students) of Portugal in 2002 to that in 2004?
Your response must be concise. 0.97. What is the ratio of the Female students (as % of total students) in Morocco in 2002 to that in 2005?
Ensure brevity in your answer.  0.97. What is the ratio of the Female students (as % of total students) in Portugal in 2002 to that in 2005?
Ensure brevity in your answer.  0.96. What is the ratio of the Female students (as % of total students) of Slovenia in 2002 to that in 2005?
Make the answer very short. 0.99. What is the ratio of the Female students (as % of total students) of Morocco in 2003 to that in 2004?
Make the answer very short. 0.99. What is the ratio of the Female students (as % of total students) in Portugal in 2003 to that in 2004?
Give a very brief answer. 0.98. What is the ratio of the Female students (as % of total students) of High income: nonOECD in 2003 to that in 2005?
Your answer should be very brief. 1. What is the ratio of the Female students (as % of total students) in Morocco in 2003 to that in 2005?
Ensure brevity in your answer.  0.98. What is the ratio of the Female students (as % of total students) in Portugal in 2003 to that in 2005?
Your answer should be very brief. 0.98. What is the ratio of the Female students (as % of total students) of Slovenia in 2003 to that in 2005?
Provide a short and direct response. 0.99. What is the ratio of the Female students (as % of total students) of Morocco in 2004 to that in 2005?
Offer a very short reply. 0.99. What is the ratio of the Female students (as % of total students) of Portugal in 2004 to that in 2005?
Your response must be concise. 0.99. What is the ratio of the Female students (as % of total students) of Slovenia in 2004 to that in 2005?
Your answer should be very brief. 1. What is the difference between the highest and the second highest Female students (as % of total students) of High income: nonOECD?
Ensure brevity in your answer.  0.06. What is the difference between the highest and the second highest Female students (as % of total students) in Morocco?
Provide a succinct answer. 0.3. What is the difference between the highest and the second highest Female students (as % of total students) of Portugal?
Your answer should be compact. 0.28. What is the difference between the highest and the second highest Female students (as % of total students) of Slovenia?
Make the answer very short. 0.17. What is the difference between the highest and the lowest Female students (as % of total students) in High income: nonOECD?
Offer a terse response. 0.37. What is the difference between the highest and the lowest Female students (as % of total students) in Morocco?
Offer a terse response. 2.22. What is the difference between the highest and the lowest Female students (as % of total students) of Portugal?
Offer a very short reply. 1.92. What is the difference between the highest and the lowest Female students (as % of total students) of Slovenia?
Your response must be concise. 0.84. 